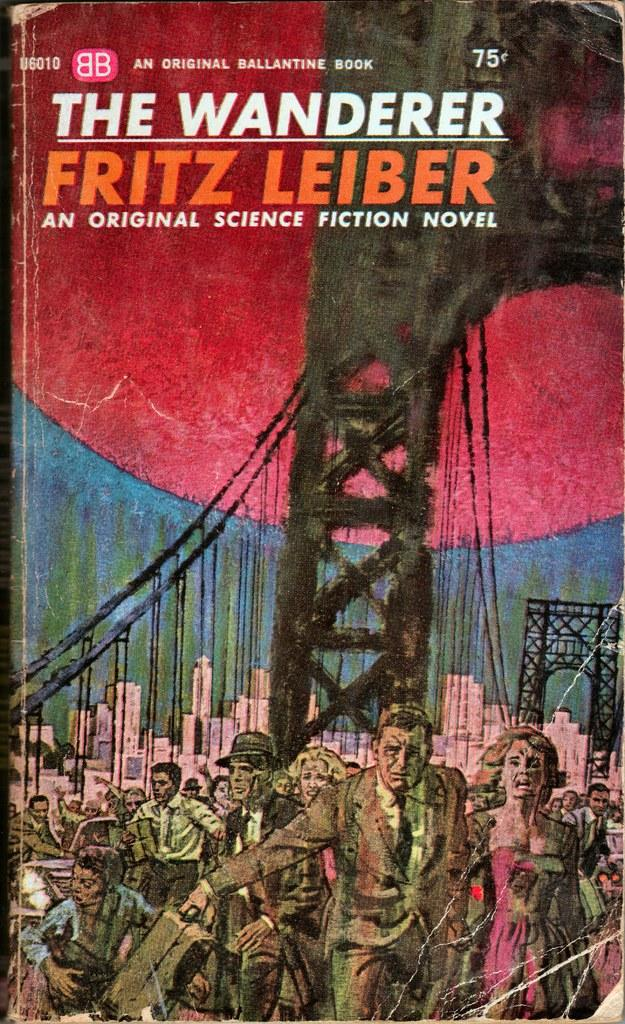<image>
Describe the image concisely. The cover of the book the wanderer written by Fritz Leiber. 